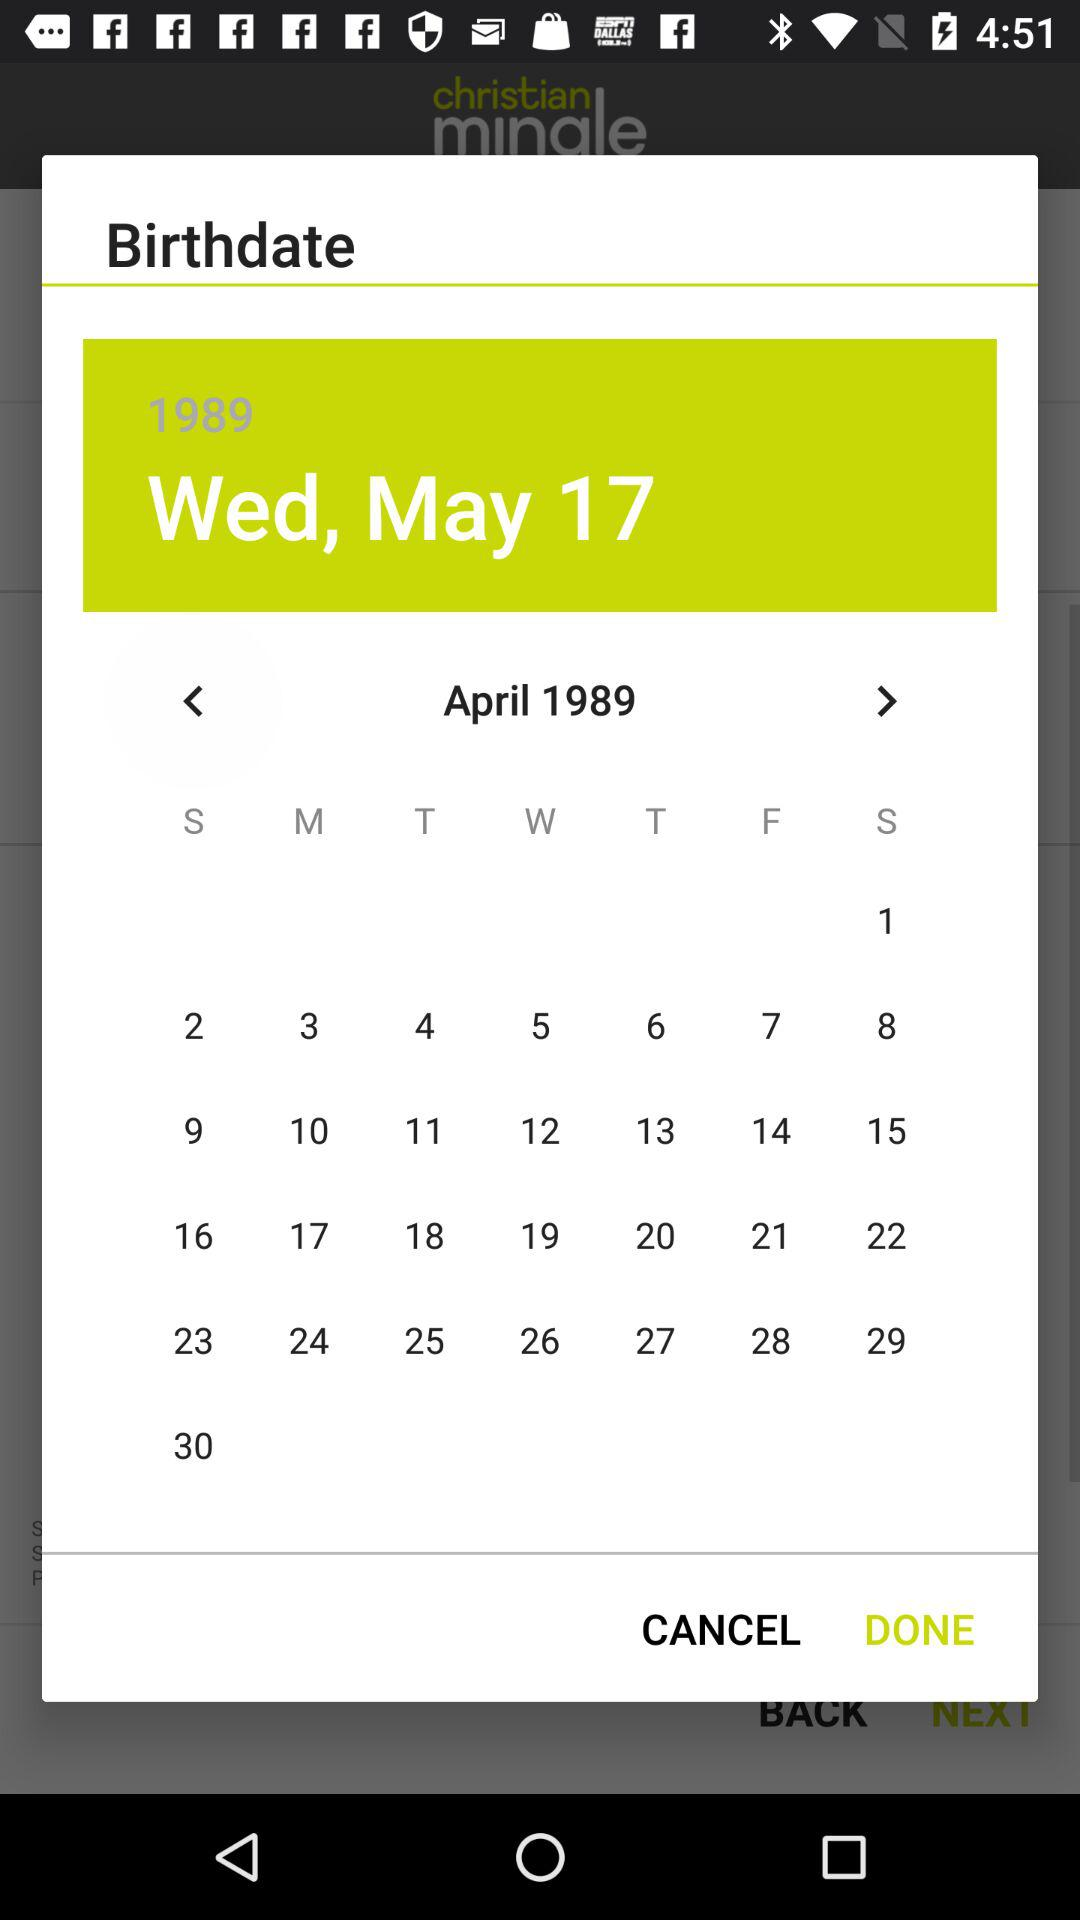What date is selected? The selected date is Wednesday, May 17, 1989. 